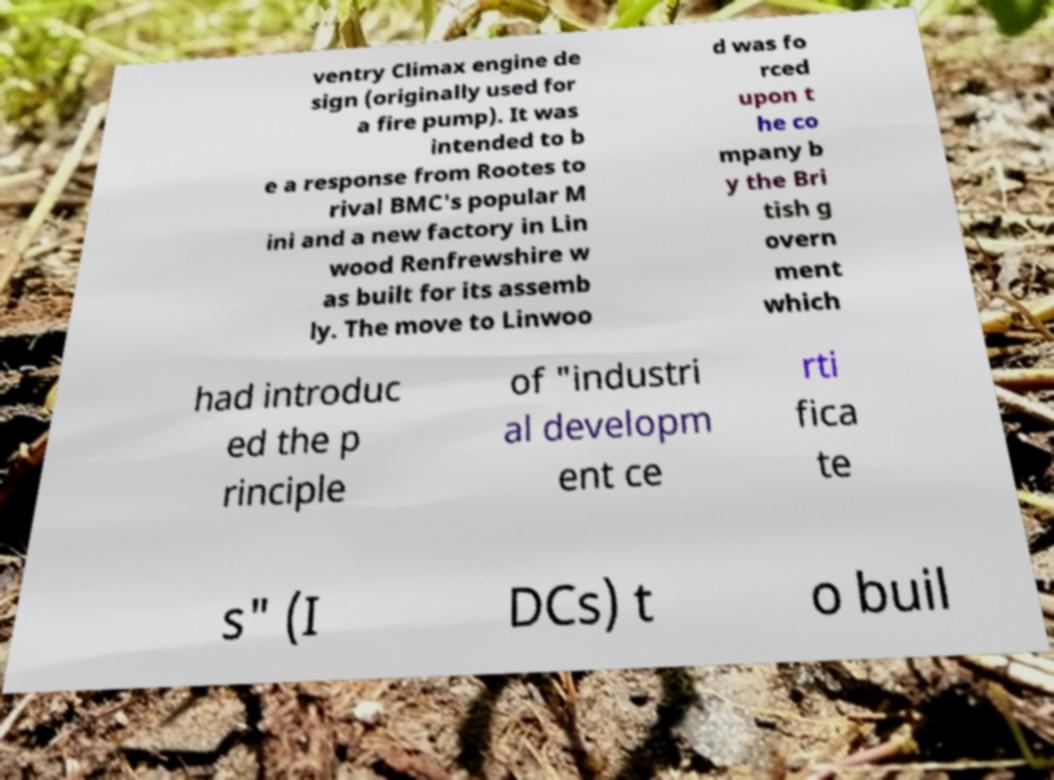There's text embedded in this image that I need extracted. Can you transcribe it verbatim? ventry Climax engine de sign (originally used for a fire pump). It was intended to b e a response from Rootes to rival BMC's popular M ini and a new factory in Lin wood Renfrewshire w as built for its assemb ly. The move to Linwoo d was fo rced upon t he co mpany b y the Bri tish g overn ment which had introduc ed the p rinciple of "industri al developm ent ce rti fica te s" (I DCs) t o buil 